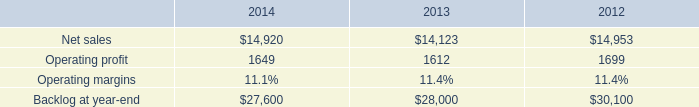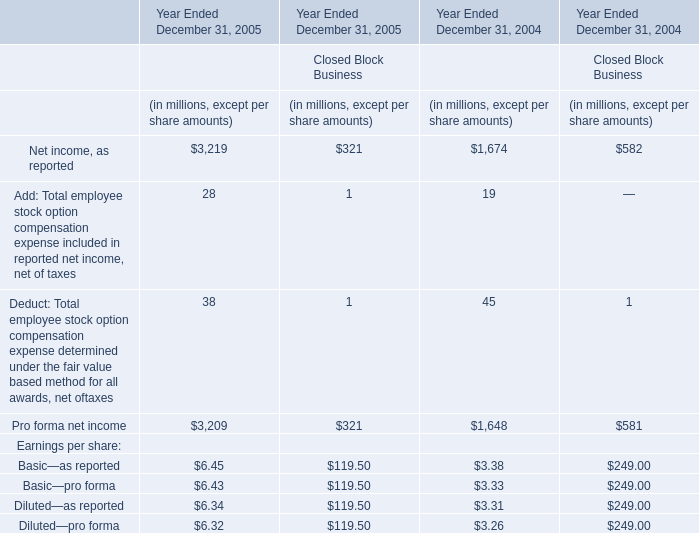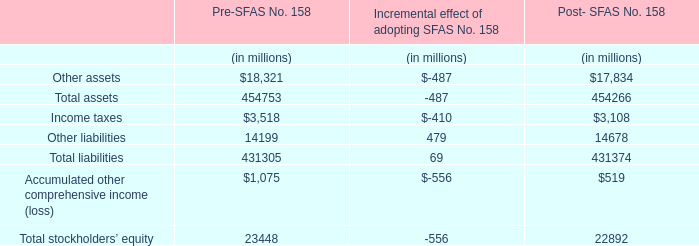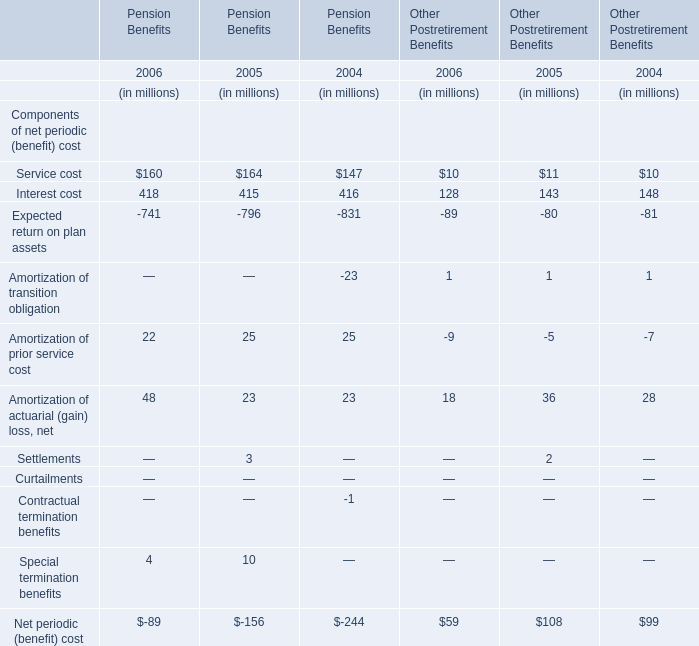What is the total value of Service cost, Interest cost, Amortization of prior service cost and Amortization of actuarial (gain) loss, net for Pension Benefits in 2006? (in million) 
Computations: (((160 + 418) + 22) + 48)
Answer: 648.0. 